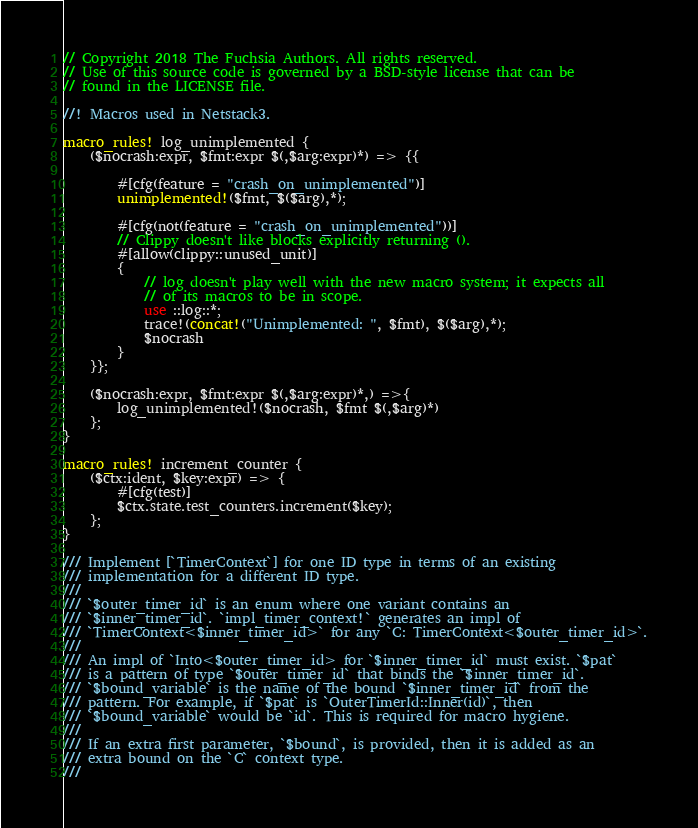<code> <loc_0><loc_0><loc_500><loc_500><_Rust_>// Copyright 2018 The Fuchsia Authors. All rights reserved.
// Use of this source code is governed by a BSD-style license that can be
// found in the LICENSE file.

//! Macros used in Netstack3.

macro_rules! log_unimplemented {
    ($nocrash:expr, $fmt:expr $(,$arg:expr)*) => {{

        #[cfg(feature = "crash_on_unimplemented")]
        unimplemented!($fmt, $($arg),*);

        #[cfg(not(feature = "crash_on_unimplemented"))]
        // Clippy doesn't like blocks explicitly returning ().
        #[allow(clippy::unused_unit)]
        {
            // log doesn't play well with the new macro system; it expects all
            // of its macros to be in scope.
            use ::log::*;
            trace!(concat!("Unimplemented: ", $fmt), $($arg),*);
            $nocrash
        }
    }};

    ($nocrash:expr, $fmt:expr $(,$arg:expr)*,) =>{
        log_unimplemented!($nocrash, $fmt $(,$arg)*)
    };
}

macro_rules! increment_counter {
    ($ctx:ident, $key:expr) => {
        #[cfg(test)]
        $ctx.state.test_counters.increment($key);
    };
}

/// Implement [`TimerContext`] for one ID type in terms of an existing
/// implementation for a different ID type.
///
/// `$outer_timer_id` is an enum where one variant contains an
/// `$inner_timer_id`. `impl_timer_context!` generates an impl of
/// `TimerContext<$inner_timer_id>` for any `C: TimerContext<$outer_timer_id>`.
///
/// An impl of `Into<$outer_timer_id> for `$inner_timer_id` must exist. `$pat`
/// is a pattern of type `$outer_timer_id` that binds the `$inner_timer_id`.
/// `$bound_variable` is the name of the bound `$inner_timer_id` from the
/// pattern. For example, if `$pat` is `OuterTimerId::Inner(id)`, then
/// `$bound_variable` would be `id`. This is required for macro hygiene.
///
/// If an extra first parameter, `$bound`, is provided, then it is added as an
/// extra bound on the `C` context type.
///</code> 